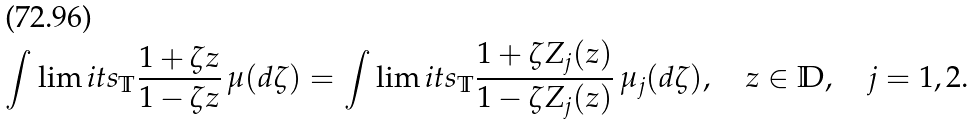<formula> <loc_0><loc_0><loc_500><loc_500>\int \lim i t s _ { \mathbb { T } } \frac { 1 + \zeta z } { 1 - \zeta z } \, \mu ( d \zeta ) = \int \lim i t s _ { \mathbb { T } } \frac { 1 + \zeta Z _ { j } ( z ) } { 1 - \zeta Z _ { j } ( z ) } \, \mu _ { j } ( d \zeta ) , \quad z \in \mathbb { D } , \quad j = 1 , 2 .</formula> 